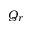<formula> <loc_0><loc_0><loc_500><loc_500>Q _ { r }</formula> 